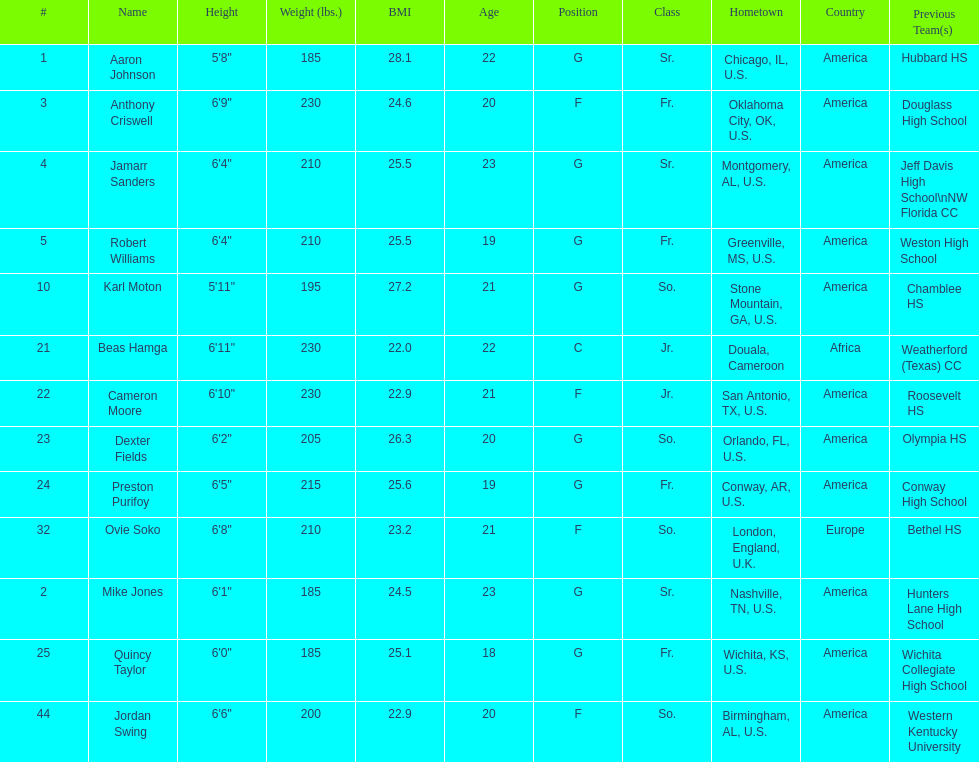Tell me the number of juniors on the team. 2. 